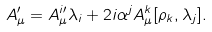<formula> <loc_0><loc_0><loc_500><loc_500>A _ { \mu } ^ { \prime } = A _ { \mu } ^ { i \prime } \lambda _ { i } + 2 i \alpha ^ { j } A _ { \mu } ^ { k } [ \rho _ { k } , \lambda _ { j } ] .</formula> 